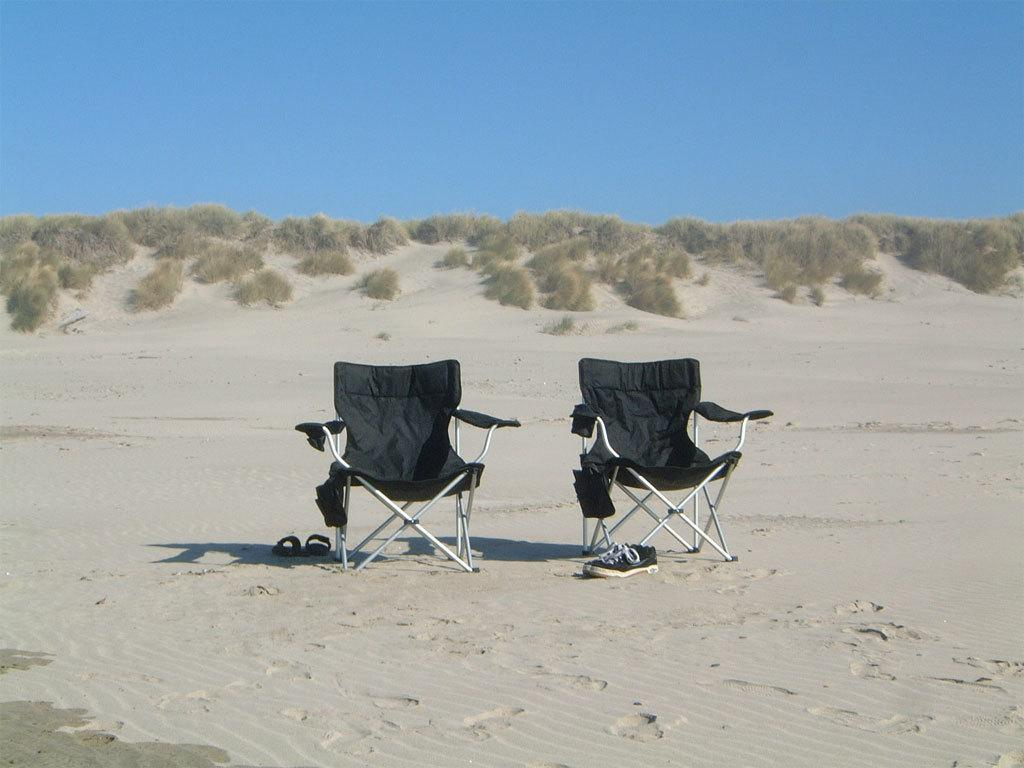How many chairs are present in the image? There are two chairs in the image. What else can be seen on the ground in the image? There are foot wears on the ground in the image. What is visible in the background of the image? There are planets and the sky visible in the background of the image. What type of quill is being used to write on the chairs in the image? There is no quill present in the image, and the chairs are not being used for writing. 